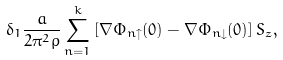<formula> <loc_0><loc_0><loc_500><loc_500>\delta _ { 1 } \frac { a } { 2 \pi ^ { 2 } \rho } \sum _ { n = 1 } ^ { k } \left [ \nabla \Phi _ { n \uparrow } ( 0 ) - \nabla \Phi _ { n \downarrow } ( 0 ) \right ] S _ { z } ,</formula> 